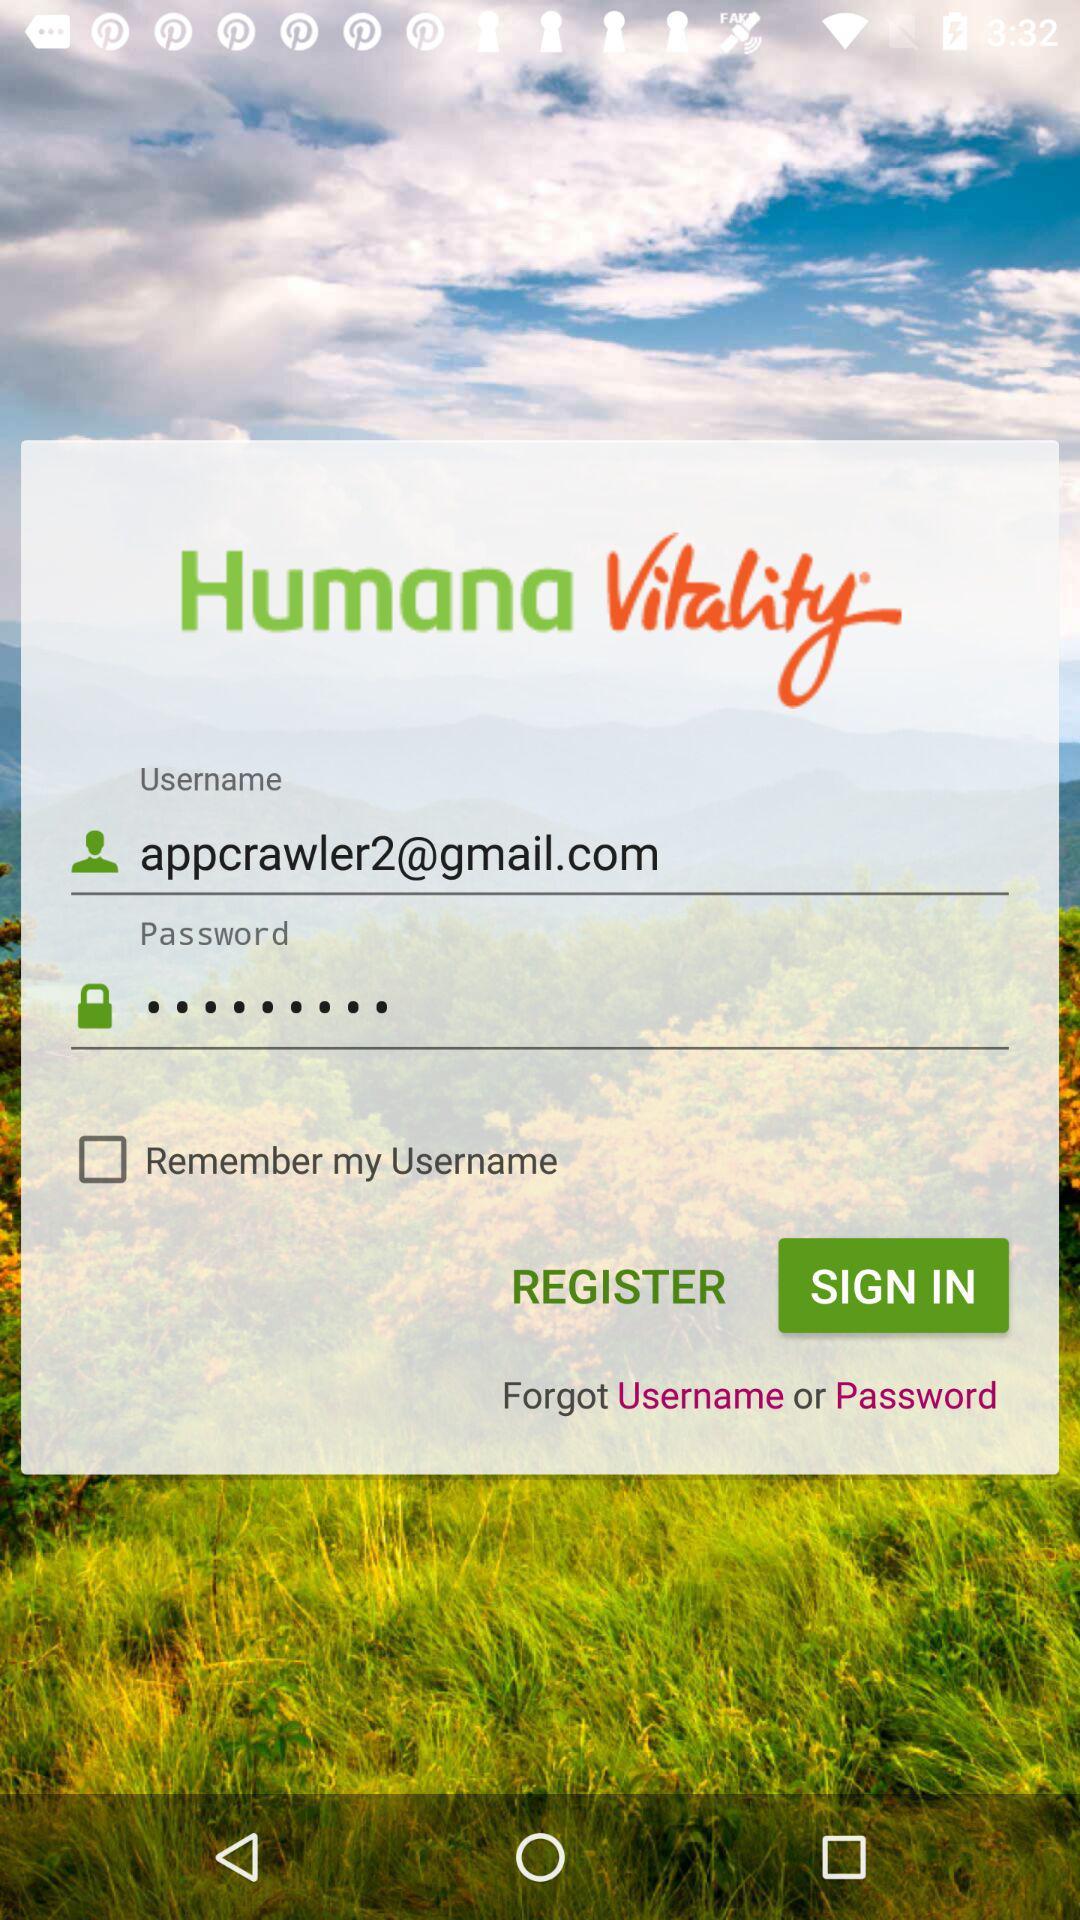How many textboxes are there on the login screen?
Answer the question using a single word or phrase. 2 